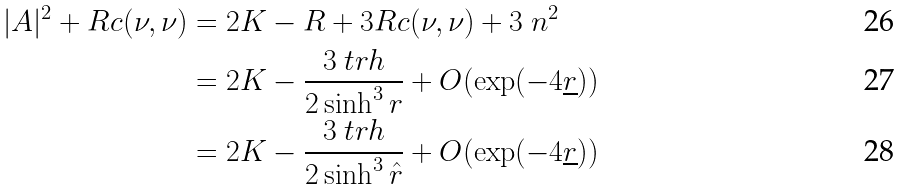Convert formula to latex. <formula><loc_0><loc_0><loc_500><loc_500>| A | ^ { 2 } + R c ( \nu , \nu ) & = 2 K - R + 3 R c ( \nu , \nu ) + 3 \ n ^ { 2 } \\ & = 2 K - \frac { 3 \ t r h } { 2 \sinh ^ { 3 } r } + O ( \exp ( - 4 \underline { r } ) ) \\ & = 2 K - \frac { 3 \ t r h } { 2 \sinh ^ { 3 } \hat { r } } + O ( \exp ( - 4 \underline { r } ) )</formula> 